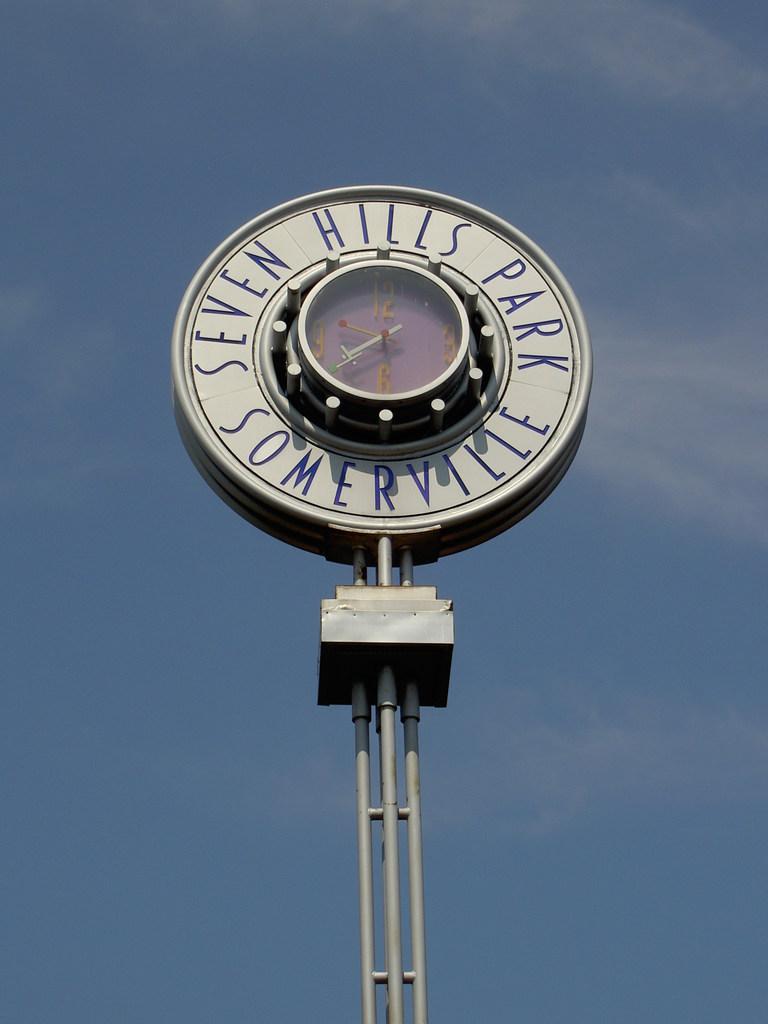What park is this clock at?
Offer a terse response. Seven hills park. What is time time displayed on the clock?
Your response must be concise. 9:40. 